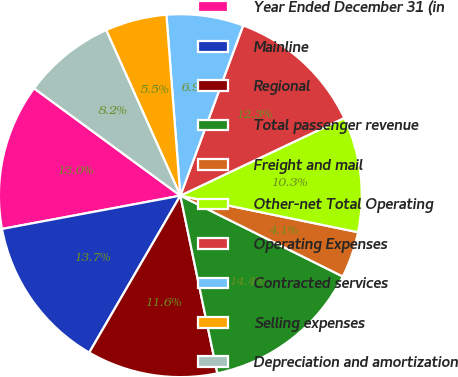Convert chart to OTSL. <chart><loc_0><loc_0><loc_500><loc_500><pie_chart><fcel>Year Ended December 31 (in<fcel>Mainline<fcel>Regional<fcel>Total passenger revenue<fcel>Freight and mail<fcel>Other-net Total Operating<fcel>Operating Expenses<fcel>Contracted services<fcel>Selling expenses<fcel>Depreciation and amortization<nl><fcel>13.01%<fcel>13.69%<fcel>11.64%<fcel>14.38%<fcel>4.12%<fcel>10.27%<fcel>12.33%<fcel>6.85%<fcel>5.48%<fcel>8.22%<nl></chart> 